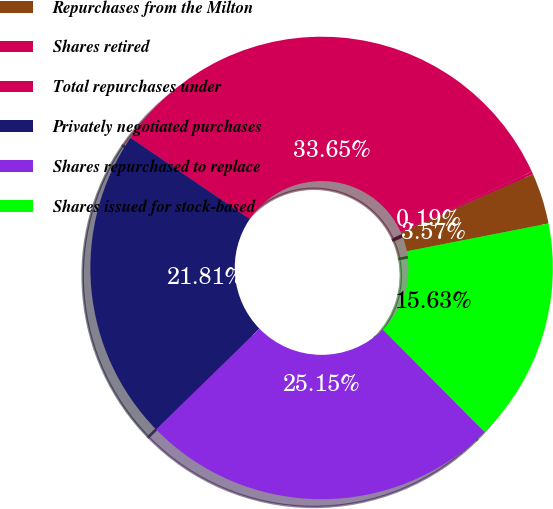Convert chart to OTSL. <chart><loc_0><loc_0><loc_500><loc_500><pie_chart><fcel>Repurchases from the Milton<fcel>Shares retired<fcel>Total repurchases under<fcel>Privately negotiated purchases<fcel>Shares repurchased to replace<fcel>Shares issued for stock-based<nl><fcel>3.57%<fcel>0.19%<fcel>33.65%<fcel>21.81%<fcel>25.15%<fcel>15.63%<nl></chart> 